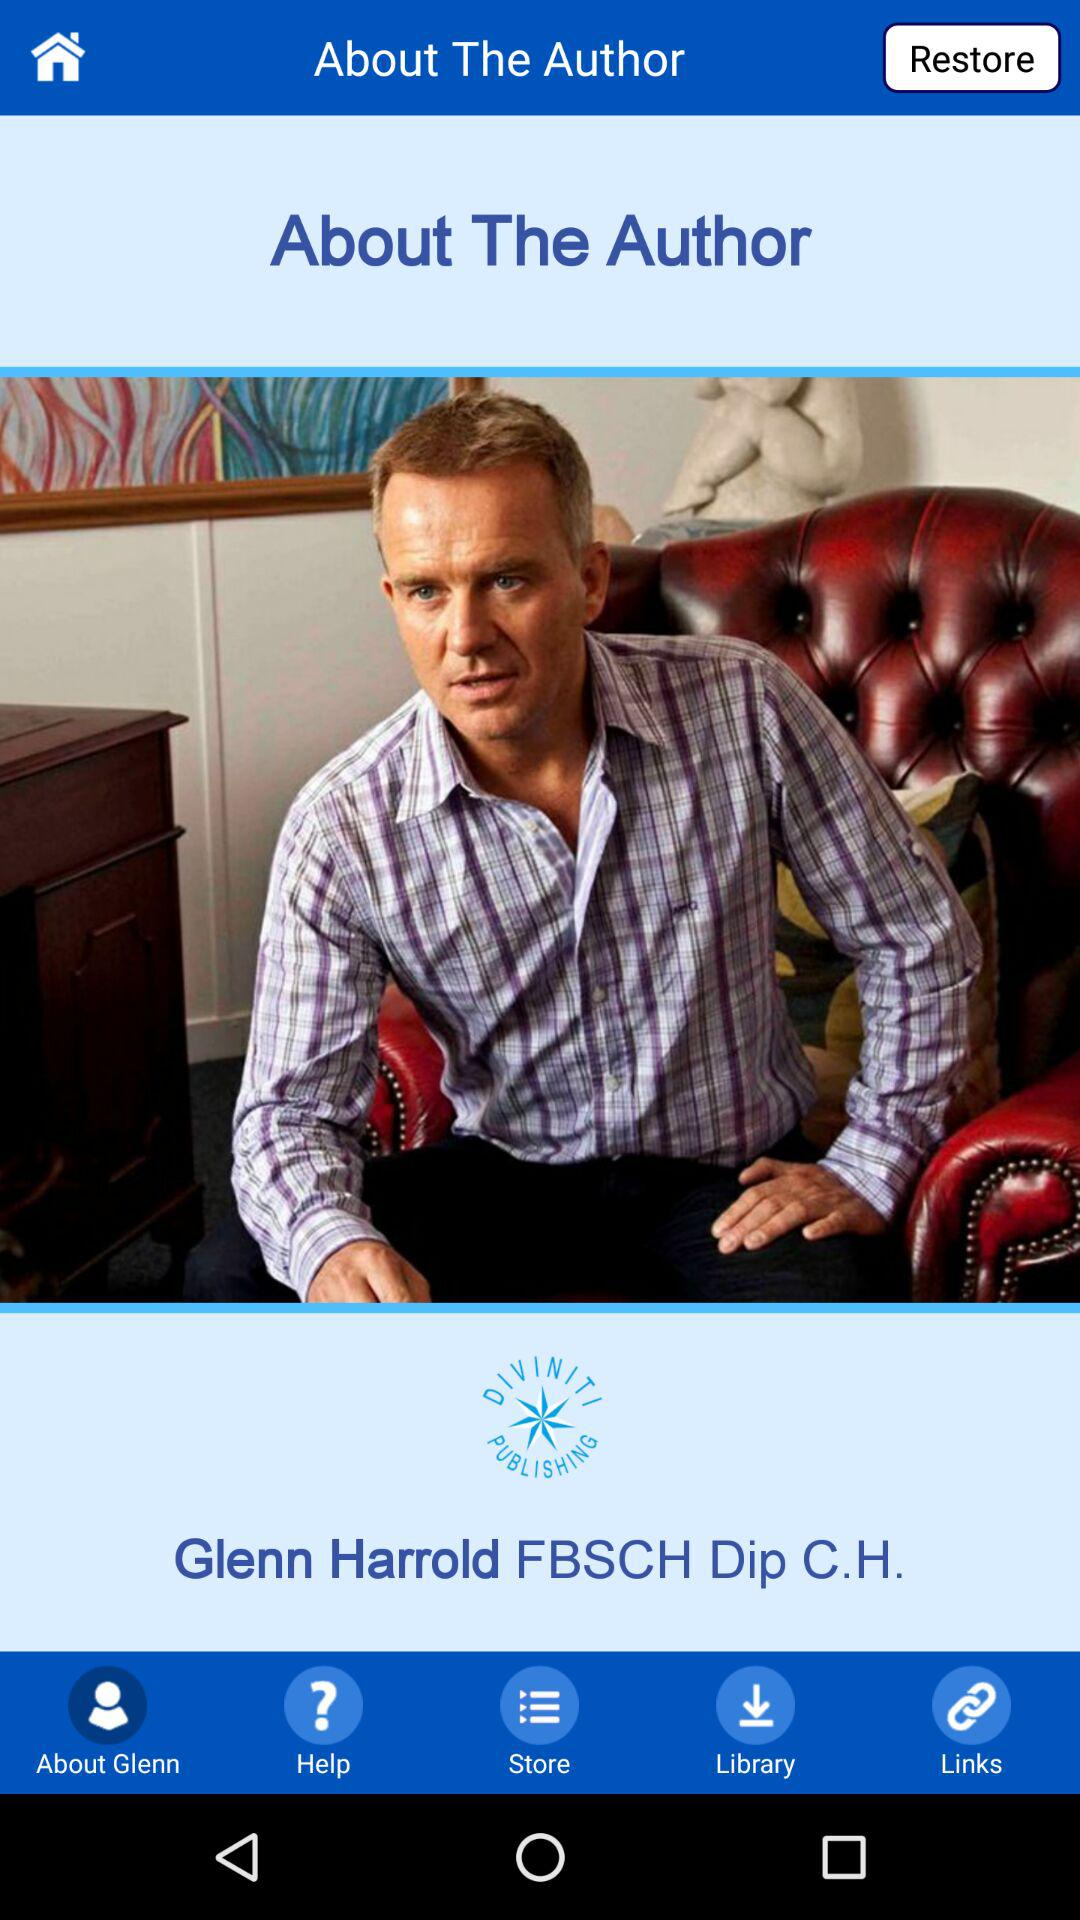Which books have been downloaded to the library?
When the provided information is insufficient, respond with <no answer>. <no answer> 